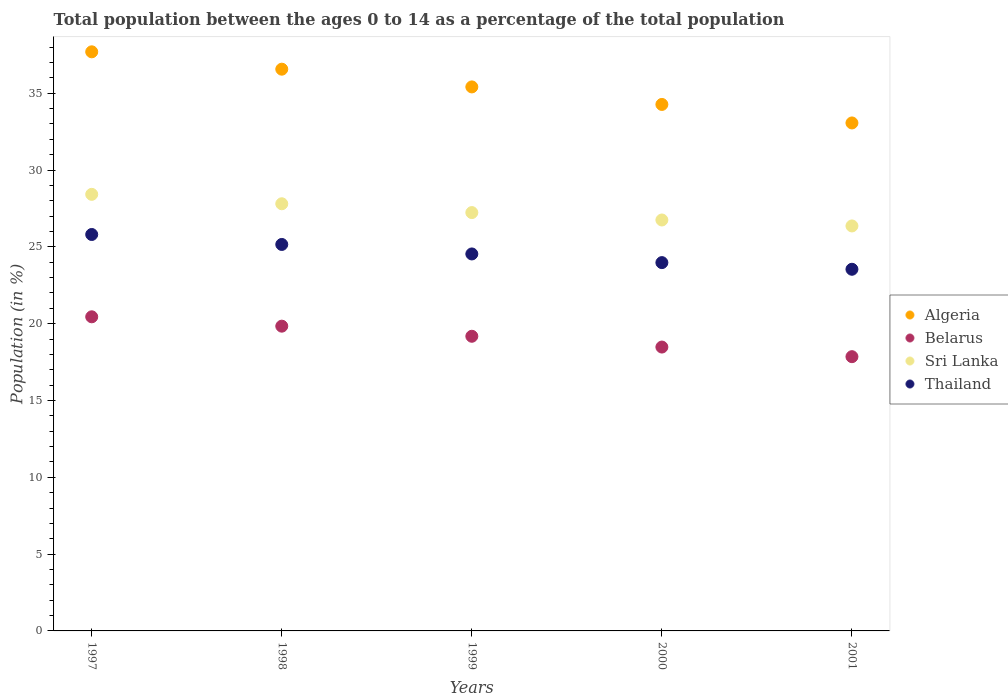How many different coloured dotlines are there?
Ensure brevity in your answer.  4. What is the percentage of the population ages 0 to 14 in Algeria in 1998?
Offer a terse response. 36.57. Across all years, what is the maximum percentage of the population ages 0 to 14 in Thailand?
Offer a terse response. 25.81. Across all years, what is the minimum percentage of the population ages 0 to 14 in Belarus?
Your response must be concise. 17.85. In which year was the percentage of the population ages 0 to 14 in Thailand minimum?
Make the answer very short. 2001. What is the total percentage of the population ages 0 to 14 in Algeria in the graph?
Your response must be concise. 177.02. What is the difference between the percentage of the population ages 0 to 14 in Belarus in 1997 and that in 1998?
Your response must be concise. 0.61. What is the difference between the percentage of the population ages 0 to 14 in Belarus in 1997 and the percentage of the population ages 0 to 14 in Thailand in 1999?
Provide a succinct answer. -4.09. What is the average percentage of the population ages 0 to 14 in Thailand per year?
Offer a terse response. 24.6. In the year 2001, what is the difference between the percentage of the population ages 0 to 14 in Belarus and percentage of the population ages 0 to 14 in Sri Lanka?
Offer a very short reply. -8.51. In how many years, is the percentage of the population ages 0 to 14 in Algeria greater than 2?
Keep it short and to the point. 5. What is the ratio of the percentage of the population ages 0 to 14 in Sri Lanka in 1997 to that in 2000?
Ensure brevity in your answer.  1.06. Is the difference between the percentage of the population ages 0 to 14 in Belarus in 1998 and 2001 greater than the difference between the percentage of the population ages 0 to 14 in Sri Lanka in 1998 and 2001?
Give a very brief answer. Yes. What is the difference between the highest and the second highest percentage of the population ages 0 to 14 in Belarus?
Provide a succinct answer. 0.61. What is the difference between the highest and the lowest percentage of the population ages 0 to 14 in Thailand?
Offer a terse response. 2.26. Is it the case that in every year, the sum of the percentage of the population ages 0 to 14 in Thailand and percentage of the population ages 0 to 14 in Algeria  is greater than the percentage of the population ages 0 to 14 in Sri Lanka?
Make the answer very short. Yes. Is the percentage of the population ages 0 to 14 in Thailand strictly greater than the percentage of the population ages 0 to 14 in Algeria over the years?
Your answer should be compact. No. How many dotlines are there?
Give a very brief answer. 4. Where does the legend appear in the graph?
Make the answer very short. Center right. How many legend labels are there?
Provide a short and direct response. 4. What is the title of the graph?
Ensure brevity in your answer.  Total population between the ages 0 to 14 as a percentage of the total population. Does "Benin" appear as one of the legend labels in the graph?
Offer a very short reply. No. What is the label or title of the X-axis?
Make the answer very short. Years. What is the label or title of the Y-axis?
Your response must be concise. Population (in %). What is the Population (in %) of Algeria in 1997?
Give a very brief answer. 37.7. What is the Population (in %) of Belarus in 1997?
Make the answer very short. 20.45. What is the Population (in %) in Sri Lanka in 1997?
Ensure brevity in your answer.  28.42. What is the Population (in %) in Thailand in 1997?
Offer a very short reply. 25.81. What is the Population (in %) in Algeria in 1998?
Keep it short and to the point. 36.57. What is the Population (in %) in Belarus in 1998?
Offer a very short reply. 19.84. What is the Population (in %) of Sri Lanka in 1998?
Offer a very short reply. 27.81. What is the Population (in %) in Thailand in 1998?
Offer a terse response. 25.16. What is the Population (in %) of Algeria in 1999?
Make the answer very short. 35.41. What is the Population (in %) in Belarus in 1999?
Offer a terse response. 19.18. What is the Population (in %) in Sri Lanka in 1999?
Ensure brevity in your answer.  27.23. What is the Population (in %) in Thailand in 1999?
Offer a very short reply. 24.54. What is the Population (in %) of Algeria in 2000?
Provide a short and direct response. 34.27. What is the Population (in %) in Belarus in 2000?
Ensure brevity in your answer.  18.48. What is the Population (in %) in Sri Lanka in 2000?
Offer a terse response. 26.75. What is the Population (in %) in Thailand in 2000?
Provide a short and direct response. 23.98. What is the Population (in %) of Algeria in 2001?
Provide a succinct answer. 33.07. What is the Population (in %) in Belarus in 2001?
Your answer should be compact. 17.85. What is the Population (in %) in Sri Lanka in 2001?
Provide a succinct answer. 26.36. What is the Population (in %) in Thailand in 2001?
Your answer should be very brief. 23.54. Across all years, what is the maximum Population (in %) of Algeria?
Your answer should be very brief. 37.7. Across all years, what is the maximum Population (in %) of Belarus?
Give a very brief answer. 20.45. Across all years, what is the maximum Population (in %) in Sri Lanka?
Offer a terse response. 28.42. Across all years, what is the maximum Population (in %) in Thailand?
Make the answer very short. 25.81. Across all years, what is the minimum Population (in %) in Algeria?
Your answer should be compact. 33.07. Across all years, what is the minimum Population (in %) of Belarus?
Your response must be concise. 17.85. Across all years, what is the minimum Population (in %) in Sri Lanka?
Make the answer very short. 26.36. Across all years, what is the minimum Population (in %) of Thailand?
Your answer should be compact. 23.54. What is the total Population (in %) of Algeria in the graph?
Offer a very short reply. 177.02. What is the total Population (in %) of Belarus in the graph?
Make the answer very short. 95.8. What is the total Population (in %) in Sri Lanka in the graph?
Provide a succinct answer. 136.57. What is the total Population (in %) in Thailand in the graph?
Provide a short and direct response. 123.02. What is the difference between the Population (in %) in Algeria in 1997 and that in 1998?
Provide a short and direct response. 1.13. What is the difference between the Population (in %) of Belarus in 1997 and that in 1998?
Make the answer very short. 0.61. What is the difference between the Population (in %) in Sri Lanka in 1997 and that in 1998?
Offer a very short reply. 0.61. What is the difference between the Population (in %) in Thailand in 1997 and that in 1998?
Your answer should be very brief. 0.65. What is the difference between the Population (in %) of Algeria in 1997 and that in 1999?
Ensure brevity in your answer.  2.28. What is the difference between the Population (in %) in Belarus in 1997 and that in 1999?
Provide a succinct answer. 1.27. What is the difference between the Population (in %) of Sri Lanka in 1997 and that in 1999?
Ensure brevity in your answer.  1.19. What is the difference between the Population (in %) in Thailand in 1997 and that in 1999?
Ensure brevity in your answer.  1.27. What is the difference between the Population (in %) in Algeria in 1997 and that in 2000?
Offer a terse response. 3.43. What is the difference between the Population (in %) in Belarus in 1997 and that in 2000?
Make the answer very short. 1.97. What is the difference between the Population (in %) in Sri Lanka in 1997 and that in 2000?
Keep it short and to the point. 1.67. What is the difference between the Population (in %) of Thailand in 1997 and that in 2000?
Offer a terse response. 1.83. What is the difference between the Population (in %) in Algeria in 1997 and that in 2001?
Your answer should be very brief. 4.63. What is the difference between the Population (in %) in Belarus in 1997 and that in 2001?
Keep it short and to the point. 2.6. What is the difference between the Population (in %) in Sri Lanka in 1997 and that in 2001?
Give a very brief answer. 2.06. What is the difference between the Population (in %) of Thailand in 1997 and that in 2001?
Your answer should be very brief. 2.26. What is the difference between the Population (in %) in Algeria in 1998 and that in 1999?
Provide a short and direct response. 1.15. What is the difference between the Population (in %) of Belarus in 1998 and that in 1999?
Provide a short and direct response. 0.66. What is the difference between the Population (in %) in Sri Lanka in 1998 and that in 1999?
Provide a short and direct response. 0.57. What is the difference between the Population (in %) of Thailand in 1998 and that in 1999?
Provide a succinct answer. 0.62. What is the difference between the Population (in %) in Algeria in 1998 and that in 2000?
Provide a short and direct response. 2.3. What is the difference between the Population (in %) of Belarus in 1998 and that in 2000?
Offer a very short reply. 1.36. What is the difference between the Population (in %) in Sri Lanka in 1998 and that in 2000?
Ensure brevity in your answer.  1.06. What is the difference between the Population (in %) of Thailand in 1998 and that in 2000?
Your answer should be compact. 1.18. What is the difference between the Population (in %) of Algeria in 1998 and that in 2001?
Your answer should be very brief. 3.5. What is the difference between the Population (in %) of Belarus in 1998 and that in 2001?
Provide a succinct answer. 1.99. What is the difference between the Population (in %) in Sri Lanka in 1998 and that in 2001?
Give a very brief answer. 1.44. What is the difference between the Population (in %) of Thailand in 1998 and that in 2001?
Give a very brief answer. 1.62. What is the difference between the Population (in %) of Algeria in 1999 and that in 2000?
Provide a short and direct response. 1.14. What is the difference between the Population (in %) in Belarus in 1999 and that in 2000?
Offer a terse response. 0.7. What is the difference between the Population (in %) in Sri Lanka in 1999 and that in 2000?
Provide a succinct answer. 0.48. What is the difference between the Population (in %) of Thailand in 1999 and that in 2000?
Provide a succinct answer. 0.56. What is the difference between the Population (in %) in Algeria in 1999 and that in 2001?
Your answer should be compact. 2.35. What is the difference between the Population (in %) in Belarus in 1999 and that in 2001?
Provide a succinct answer. 1.33. What is the difference between the Population (in %) of Sri Lanka in 1999 and that in 2001?
Your answer should be compact. 0.87. What is the difference between the Population (in %) of Thailand in 1999 and that in 2001?
Ensure brevity in your answer.  1. What is the difference between the Population (in %) in Algeria in 2000 and that in 2001?
Your answer should be compact. 1.2. What is the difference between the Population (in %) in Belarus in 2000 and that in 2001?
Give a very brief answer. 0.63. What is the difference between the Population (in %) of Sri Lanka in 2000 and that in 2001?
Your answer should be compact. 0.39. What is the difference between the Population (in %) in Thailand in 2000 and that in 2001?
Make the answer very short. 0.43. What is the difference between the Population (in %) of Algeria in 1997 and the Population (in %) of Belarus in 1998?
Offer a terse response. 17.86. What is the difference between the Population (in %) in Algeria in 1997 and the Population (in %) in Sri Lanka in 1998?
Your response must be concise. 9.89. What is the difference between the Population (in %) of Algeria in 1997 and the Population (in %) of Thailand in 1998?
Keep it short and to the point. 12.54. What is the difference between the Population (in %) of Belarus in 1997 and the Population (in %) of Sri Lanka in 1998?
Your response must be concise. -7.36. What is the difference between the Population (in %) of Belarus in 1997 and the Population (in %) of Thailand in 1998?
Your answer should be very brief. -4.71. What is the difference between the Population (in %) in Sri Lanka in 1997 and the Population (in %) in Thailand in 1998?
Your answer should be compact. 3.26. What is the difference between the Population (in %) in Algeria in 1997 and the Population (in %) in Belarus in 1999?
Your answer should be compact. 18.52. What is the difference between the Population (in %) of Algeria in 1997 and the Population (in %) of Sri Lanka in 1999?
Ensure brevity in your answer.  10.47. What is the difference between the Population (in %) of Algeria in 1997 and the Population (in %) of Thailand in 1999?
Provide a succinct answer. 13.16. What is the difference between the Population (in %) in Belarus in 1997 and the Population (in %) in Sri Lanka in 1999?
Give a very brief answer. -6.79. What is the difference between the Population (in %) in Belarus in 1997 and the Population (in %) in Thailand in 1999?
Provide a short and direct response. -4.09. What is the difference between the Population (in %) of Sri Lanka in 1997 and the Population (in %) of Thailand in 1999?
Keep it short and to the point. 3.88. What is the difference between the Population (in %) in Algeria in 1997 and the Population (in %) in Belarus in 2000?
Ensure brevity in your answer.  19.22. What is the difference between the Population (in %) of Algeria in 1997 and the Population (in %) of Sri Lanka in 2000?
Offer a very short reply. 10.95. What is the difference between the Population (in %) in Algeria in 1997 and the Population (in %) in Thailand in 2000?
Provide a succinct answer. 13.72. What is the difference between the Population (in %) in Belarus in 1997 and the Population (in %) in Sri Lanka in 2000?
Your response must be concise. -6.3. What is the difference between the Population (in %) of Belarus in 1997 and the Population (in %) of Thailand in 2000?
Offer a very short reply. -3.53. What is the difference between the Population (in %) in Sri Lanka in 1997 and the Population (in %) in Thailand in 2000?
Keep it short and to the point. 4.44. What is the difference between the Population (in %) of Algeria in 1997 and the Population (in %) of Belarus in 2001?
Your answer should be very brief. 19.85. What is the difference between the Population (in %) of Algeria in 1997 and the Population (in %) of Sri Lanka in 2001?
Give a very brief answer. 11.34. What is the difference between the Population (in %) of Algeria in 1997 and the Population (in %) of Thailand in 2001?
Give a very brief answer. 14.16. What is the difference between the Population (in %) of Belarus in 1997 and the Population (in %) of Sri Lanka in 2001?
Give a very brief answer. -5.92. What is the difference between the Population (in %) in Belarus in 1997 and the Population (in %) in Thailand in 2001?
Give a very brief answer. -3.1. What is the difference between the Population (in %) in Sri Lanka in 1997 and the Population (in %) in Thailand in 2001?
Your response must be concise. 4.88. What is the difference between the Population (in %) in Algeria in 1998 and the Population (in %) in Belarus in 1999?
Your answer should be very brief. 17.39. What is the difference between the Population (in %) of Algeria in 1998 and the Population (in %) of Sri Lanka in 1999?
Provide a succinct answer. 9.34. What is the difference between the Population (in %) in Algeria in 1998 and the Population (in %) in Thailand in 1999?
Provide a succinct answer. 12.03. What is the difference between the Population (in %) in Belarus in 1998 and the Population (in %) in Sri Lanka in 1999?
Offer a very short reply. -7.39. What is the difference between the Population (in %) in Belarus in 1998 and the Population (in %) in Thailand in 1999?
Offer a very short reply. -4.7. What is the difference between the Population (in %) in Sri Lanka in 1998 and the Population (in %) in Thailand in 1999?
Offer a terse response. 3.27. What is the difference between the Population (in %) of Algeria in 1998 and the Population (in %) of Belarus in 2000?
Offer a terse response. 18.09. What is the difference between the Population (in %) of Algeria in 1998 and the Population (in %) of Sri Lanka in 2000?
Your response must be concise. 9.82. What is the difference between the Population (in %) of Algeria in 1998 and the Population (in %) of Thailand in 2000?
Keep it short and to the point. 12.59. What is the difference between the Population (in %) of Belarus in 1998 and the Population (in %) of Sri Lanka in 2000?
Your response must be concise. -6.91. What is the difference between the Population (in %) in Belarus in 1998 and the Population (in %) in Thailand in 2000?
Provide a short and direct response. -4.14. What is the difference between the Population (in %) in Sri Lanka in 1998 and the Population (in %) in Thailand in 2000?
Ensure brevity in your answer.  3.83. What is the difference between the Population (in %) in Algeria in 1998 and the Population (in %) in Belarus in 2001?
Make the answer very short. 18.71. What is the difference between the Population (in %) of Algeria in 1998 and the Population (in %) of Sri Lanka in 2001?
Give a very brief answer. 10.21. What is the difference between the Population (in %) in Algeria in 1998 and the Population (in %) in Thailand in 2001?
Make the answer very short. 13.03. What is the difference between the Population (in %) of Belarus in 1998 and the Population (in %) of Sri Lanka in 2001?
Your answer should be compact. -6.52. What is the difference between the Population (in %) in Belarus in 1998 and the Population (in %) in Thailand in 2001?
Give a very brief answer. -3.7. What is the difference between the Population (in %) in Sri Lanka in 1998 and the Population (in %) in Thailand in 2001?
Your answer should be very brief. 4.26. What is the difference between the Population (in %) of Algeria in 1999 and the Population (in %) of Belarus in 2000?
Offer a terse response. 16.93. What is the difference between the Population (in %) of Algeria in 1999 and the Population (in %) of Sri Lanka in 2000?
Your answer should be very brief. 8.66. What is the difference between the Population (in %) of Algeria in 1999 and the Population (in %) of Thailand in 2000?
Offer a very short reply. 11.44. What is the difference between the Population (in %) of Belarus in 1999 and the Population (in %) of Sri Lanka in 2000?
Provide a succinct answer. -7.57. What is the difference between the Population (in %) in Belarus in 1999 and the Population (in %) in Thailand in 2000?
Provide a short and direct response. -4.79. What is the difference between the Population (in %) in Sri Lanka in 1999 and the Population (in %) in Thailand in 2000?
Make the answer very short. 3.26. What is the difference between the Population (in %) of Algeria in 1999 and the Population (in %) of Belarus in 2001?
Your answer should be compact. 17.56. What is the difference between the Population (in %) of Algeria in 1999 and the Population (in %) of Sri Lanka in 2001?
Offer a terse response. 9.05. What is the difference between the Population (in %) in Algeria in 1999 and the Population (in %) in Thailand in 2001?
Give a very brief answer. 11.87. What is the difference between the Population (in %) of Belarus in 1999 and the Population (in %) of Sri Lanka in 2001?
Make the answer very short. -7.18. What is the difference between the Population (in %) of Belarus in 1999 and the Population (in %) of Thailand in 2001?
Provide a short and direct response. -4.36. What is the difference between the Population (in %) in Sri Lanka in 1999 and the Population (in %) in Thailand in 2001?
Your answer should be compact. 3.69. What is the difference between the Population (in %) in Algeria in 2000 and the Population (in %) in Belarus in 2001?
Make the answer very short. 16.42. What is the difference between the Population (in %) in Algeria in 2000 and the Population (in %) in Sri Lanka in 2001?
Provide a succinct answer. 7.91. What is the difference between the Population (in %) of Algeria in 2000 and the Population (in %) of Thailand in 2001?
Offer a terse response. 10.73. What is the difference between the Population (in %) of Belarus in 2000 and the Population (in %) of Sri Lanka in 2001?
Your response must be concise. -7.88. What is the difference between the Population (in %) in Belarus in 2000 and the Population (in %) in Thailand in 2001?
Your answer should be very brief. -5.06. What is the difference between the Population (in %) of Sri Lanka in 2000 and the Population (in %) of Thailand in 2001?
Your answer should be compact. 3.21. What is the average Population (in %) in Algeria per year?
Provide a short and direct response. 35.4. What is the average Population (in %) in Belarus per year?
Your response must be concise. 19.16. What is the average Population (in %) of Sri Lanka per year?
Ensure brevity in your answer.  27.31. What is the average Population (in %) of Thailand per year?
Offer a very short reply. 24.6. In the year 1997, what is the difference between the Population (in %) in Algeria and Population (in %) in Belarus?
Offer a terse response. 17.25. In the year 1997, what is the difference between the Population (in %) in Algeria and Population (in %) in Sri Lanka?
Provide a short and direct response. 9.28. In the year 1997, what is the difference between the Population (in %) of Algeria and Population (in %) of Thailand?
Provide a short and direct response. 11.89. In the year 1997, what is the difference between the Population (in %) of Belarus and Population (in %) of Sri Lanka?
Give a very brief answer. -7.97. In the year 1997, what is the difference between the Population (in %) of Belarus and Population (in %) of Thailand?
Provide a short and direct response. -5.36. In the year 1997, what is the difference between the Population (in %) in Sri Lanka and Population (in %) in Thailand?
Keep it short and to the point. 2.61. In the year 1998, what is the difference between the Population (in %) of Algeria and Population (in %) of Belarus?
Provide a succinct answer. 16.73. In the year 1998, what is the difference between the Population (in %) in Algeria and Population (in %) in Sri Lanka?
Offer a terse response. 8.76. In the year 1998, what is the difference between the Population (in %) in Algeria and Population (in %) in Thailand?
Keep it short and to the point. 11.41. In the year 1998, what is the difference between the Population (in %) in Belarus and Population (in %) in Sri Lanka?
Make the answer very short. -7.97. In the year 1998, what is the difference between the Population (in %) of Belarus and Population (in %) of Thailand?
Provide a succinct answer. -5.32. In the year 1998, what is the difference between the Population (in %) of Sri Lanka and Population (in %) of Thailand?
Your response must be concise. 2.65. In the year 1999, what is the difference between the Population (in %) of Algeria and Population (in %) of Belarus?
Offer a very short reply. 16.23. In the year 1999, what is the difference between the Population (in %) of Algeria and Population (in %) of Sri Lanka?
Ensure brevity in your answer.  8.18. In the year 1999, what is the difference between the Population (in %) of Algeria and Population (in %) of Thailand?
Your answer should be very brief. 10.87. In the year 1999, what is the difference between the Population (in %) of Belarus and Population (in %) of Sri Lanka?
Make the answer very short. -8.05. In the year 1999, what is the difference between the Population (in %) of Belarus and Population (in %) of Thailand?
Your answer should be very brief. -5.36. In the year 1999, what is the difference between the Population (in %) of Sri Lanka and Population (in %) of Thailand?
Provide a short and direct response. 2.69. In the year 2000, what is the difference between the Population (in %) of Algeria and Population (in %) of Belarus?
Your answer should be very brief. 15.79. In the year 2000, what is the difference between the Population (in %) of Algeria and Population (in %) of Sri Lanka?
Make the answer very short. 7.52. In the year 2000, what is the difference between the Population (in %) in Algeria and Population (in %) in Thailand?
Give a very brief answer. 10.3. In the year 2000, what is the difference between the Population (in %) in Belarus and Population (in %) in Sri Lanka?
Make the answer very short. -8.27. In the year 2000, what is the difference between the Population (in %) of Belarus and Population (in %) of Thailand?
Offer a terse response. -5.5. In the year 2000, what is the difference between the Population (in %) in Sri Lanka and Population (in %) in Thailand?
Provide a succinct answer. 2.77. In the year 2001, what is the difference between the Population (in %) of Algeria and Population (in %) of Belarus?
Offer a terse response. 15.21. In the year 2001, what is the difference between the Population (in %) in Algeria and Population (in %) in Sri Lanka?
Make the answer very short. 6.7. In the year 2001, what is the difference between the Population (in %) of Algeria and Population (in %) of Thailand?
Your answer should be very brief. 9.52. In the year 2001, what is the difference between the Population (in %) in Belarus and Population (in %) in Sri Lanka?
Keep it short and to the point. -8.51. In the year 2001, what is the difference between the Population (in %) of Belarus and Population (in %) of Thailand?
Make the answer very short. -5.69. In the year 2001, what is the difference between the Population (in %) of Sri Lanka and Population (in %) of Thailand?
Your response must be concise. 2.82. What is the ratio of the Population (in %) in Algeria in 1997 to that in 1998?
Give a very brief answer. 1.03. What is the ratio of the Population (in %) of Belarus in 1997 to that in 1998?
Keep it short and to the point. 1.03. What is the ratio of the Population (in %) in Thailand in 1997 to that in 1998?
Make the answer very short. 1.03. What is the ratio of the Population (in %) in Algeria in 1997 to that in 1999?
Ensure brevity in your answer.  1.06. What is the ratio of the Population (in %) of Belarus in 1997 to that in 1999?
Make the answer very short. 1.07. What is the ratio of the Population (in %) in Sri Lanka in 1997 to that in 1999?
Offer a very short reply. 1.04. What is the ratio of the Population (in %) in Thailand in 1997 to that in 1999?
Offer a terse response. 1.05. What is the ratio of the Population (in %) in Belarus in 1997 to that in 2000?
Provide a succinct answer. 1.11. What is the ratio of the Population (in %) in Sri Lanka in 1997 to that in 2000?
Offer a terse response. 1.06. What is the ratio of the Population (in %) of Thailand in 1997 to that in 2000?
Your answer should be compact. 1.08. What is the ratio of the Population (in %) of Algeria in 1997 to that in 2001?
Your answer should be very brief. 1.14. What is the ratio of the Population (in %) in Belarus in 1997 to that in 2001?
Ensure brevity in your answer.  1.15. What is the ratio of the Population (in %) of Sri Lanka in 1997 to that in 2001?
Provide a short and direct response. 1.08. What is the ratio of the Population (in %) of Thailand in 1997 to that in 2001?
Offer a terse response. 1.1. What is the ratio of the Population (in %) of Algeria in 1998 to that in 1999?
Provide a succinct answer. 1.03. What is the ratio of the Population (in %) of Belarus in 1998 to that in 1999?
Your answer should be very brief. 1.03. What is the ratio of the Population (in %) in Sri Lanka in 1998 to that in 1999?
Give a very brief answer. 1.02. What is the ratio of the Population (in %) of Thailand in 1998 to that in 1999?
Make the answer very short. 1.03. What is the ratio of the Population (in %) in Algeria in 1998 to that in 2000?
Make the answer very short. 1.07. What is the ratio of the Population (in %) of Belarus in 1998 to that in 2000?
Offer a terse response. 1.07. What is the ratio of the Population (in %) of Sri Lanka in 1998 to that in 2000?
Your answer should be compact. 1.04. What is the ratio of the Population (in %) of Thailand in 1998 to that in 2000?
Your answer should be compact. 1.05. What is the ratio of the Population (in %) of Algeria in 1998 to that in 2001?
Ensure brevity in your answer.  1.11. What is the ratio of the Population (in %) in Belarus in 1998 to that in 2001?
Your answer should be compact. 1.11. What is the ratio of the Population (in %) in Sri Lanka in 1998 to that in 2001?
Provide a succinct answer. 1.05. What is the ratio of the Population (in %) in Thailand in 1998 to that in 2001?
Provide a succinct answer. 1.07. What is the ratio of the Population (in %) in Belarus in 1999 to that in 2000?
Your answer should be compact. 1.04. What is the ratio of the Population (in %) in Sri Lanka in 1999 to that in 2000?
Your response must be concise. 1.02. What is the ratio of the Population (in %) of Thailand in 1999 to that in 2000?
Make the answer very short. 1.02. What is the ratio of the Population (in %) of Algeria in 1999 to that in 2001?
Your answer should be very brief. 1.07. What is the ratio of the Population (in %) of Belarus in 1999 to that in 2001?
Offer a terse response. 1.07. What is the ratio of the Population (in %) of Sri Lanka in 1999 to that in 2001?
Offer a very short reply. 1.03. What is the ratio of the Population (in %) in Thailand in 1999 to that in 2001?
Your answer should be compact. 1.04. What is the ratio of the Population (in %) in Algeria in 2000 to that in 2001?
Give a very brief answer. 1.04. What is the ratio of the Population (in %) in Belarus in 2000 to that in 2001?
Give a very brief answer. 1.04. What is the ratio of the Population (in %) of Sri Lanka in 2000 to that in 2001?
Make the answer very short. 1.01. What is the ratio of the Population (in %) in Thailand in 2000 to that in 2001?
Your answer should be compact. 1.02. What is the difference between the highest and the second highest Population (in %) in Algeria?
Your answer should be very brief. 1.13. What is the difference between the highest and the second highest Population (in %) in Belarus?
Your answer should be very brief. 0.61. What is the difference between the highest and the second highest Population (in %) in Sri Lanka?
Keep it short and to the point. 0.61. What is the difference between the highest and the second highest Population (in %) in Thailand?
Provide a short and direct response. 0.65. What is the difference between the highest and the lowest Population (in %) in Algeria?
Your response must be concise. 4.63. What is the difference between the highest and the lowest Population (in %) in Belarus?
Provide a succinct answer. 2.6. What is the difference between the highest and the lowest Population (in %) of Sri Lanka?
Your answer should be very brief. 2.06. What is the difference between the highest and the lowest Population (in %) of Thailand?
Provide a succinct answer. 2.26. 